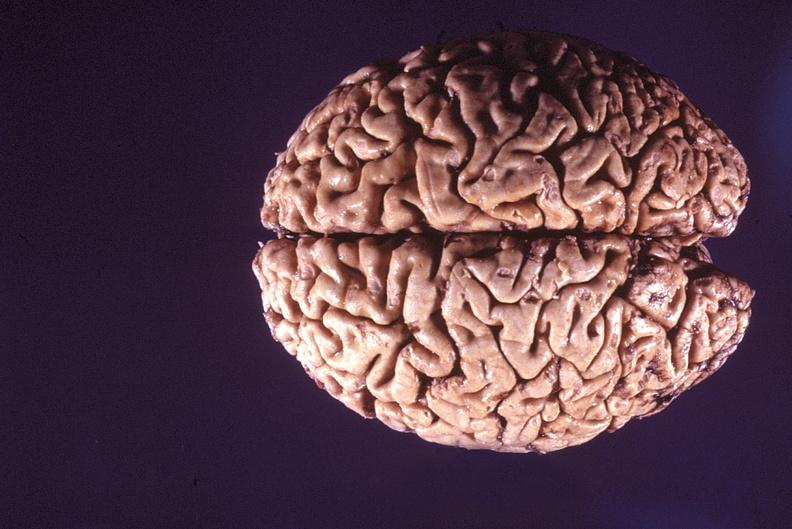what is present?
Answer the question using a single word or phrase. Nervous 